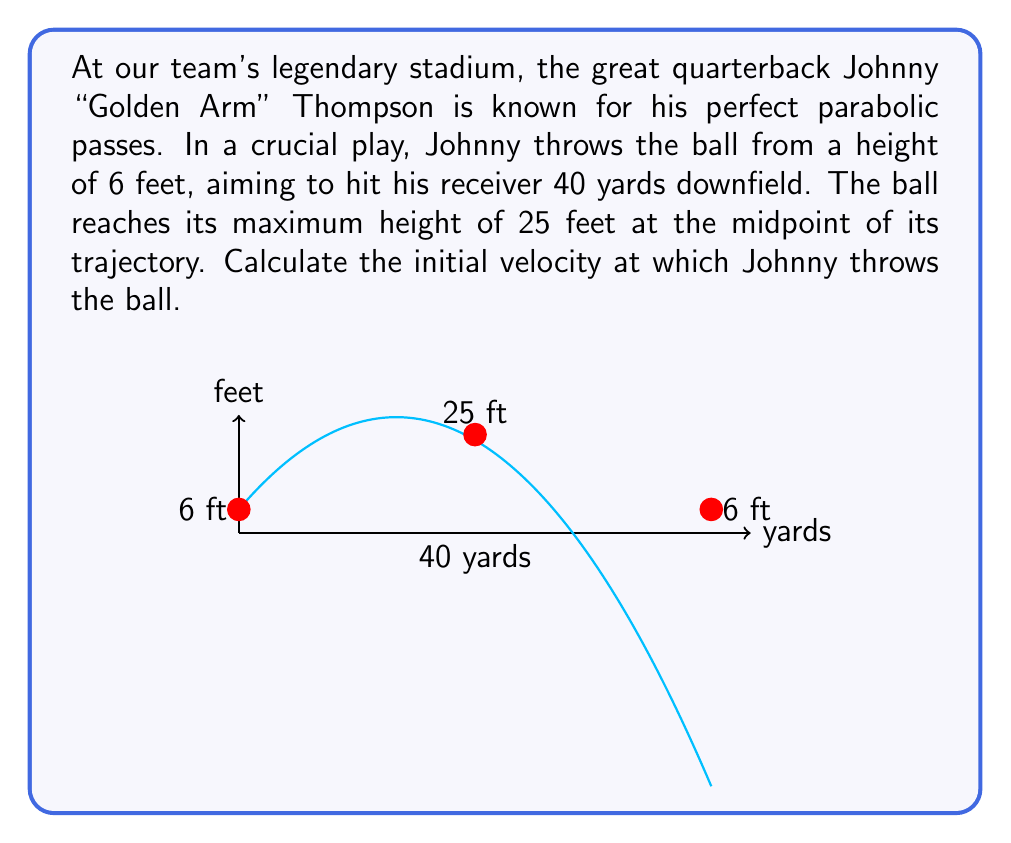Could you help me with this problem? Let's approach this step-by-step using the equations of projectile motion:

1) First, we need to set up our coordinate system. Let's use yards for horizontal distance (x) and feet for height (y). The initial point (0,6) represents Johnny's release point.

2) The general equation for a parabola is:
   $$y = ax^2 + bx + c$$

3) We know three points on this parabola:
   (0, 6) - initial point
   (20, 25) - highest point (midpoint of 40 yards)
   (40, 6) - end point

4) Substituting these into our equation:
   6 = a(0)^2 + b(0) + c
   25 = a(20)^2 + b(20) + c
   6 = a(40)^2 + b(40) + c

5) From the first equation, we can see that c = 6

6) Subtracting the first equation from the other two:
   19 = 400a + 20b
   0 = 1600a + 40b

7) Solving these simultaneously:
   b = 1.171875
   a = -0.0146484375

8) Now we have our parabola equation:
   $$y = -0.0146484375x^2 + 1.171875x + 6$$

9) The initial velocity components can be found from:
   $v_x = \frac{dx}{dt} = \text{constant}$
   $v_y = \frac{dy}{dt} = -2ax + b$ at t = 0

10) $v_x = 40$ yards in the time it takes for the ball to rise and fall, which is $\sqrt{\frac{2h}{g}}$ where h is the change in height (19 feet) and g is 32 ft/s^2.
    Time = $\sqrt{\frac{2(19)}{32}} = 1.0897$ seconds

11) So, $v_x = \frac{40}{1.0897} = 36.706$ yards/s = 110.118 ft/s

12) $v_y = b = 1.171875 * 3 = 3.515625$ yards/s = 10.54688 ft/s

13) The initial velocity is therefore:
    $$v = \sqrt{v_x^2 + v_y^2} = \sqrt{110.118^2 + 10.54688^2} = 110.62 \text{ ft/s}$$
Answer: 110.62 ft/s 